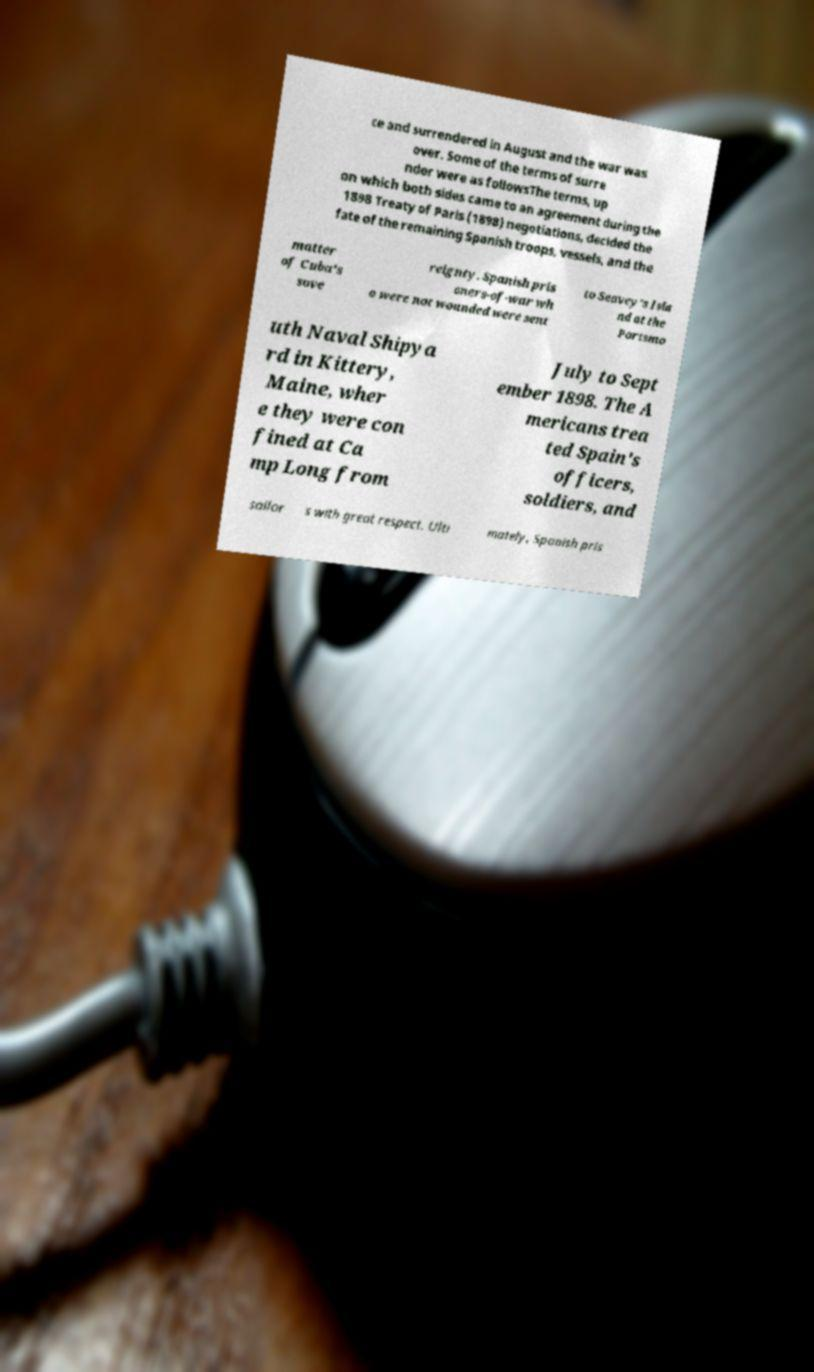Can you read and provide the text displayed in the image?This photo seems to have some interesting text. Can you extract and type it out for me? ce and surrendered in August and the war was over. Some of the terms of surre nder were as followsThe terms, up on which both sides came to an agreement during the 1898 Treaty of Paris (1898) negotiations, decided the fate of the remaining Spanish troops, vessels, and the matter of Cuba's sove reignty. Spanish pris oners-of-war wh o were not wounded were sent to Seavey's Isla nd at the Portsmo uth Naval Shipya rd in Kittery, Maine, wher e they were con fined at Ca mp Long from July to Sept ember 1898. The A mericans trea ted Spain's officers, soldiers, and sailor s with great respect. Ulti mately, Spanish pris 